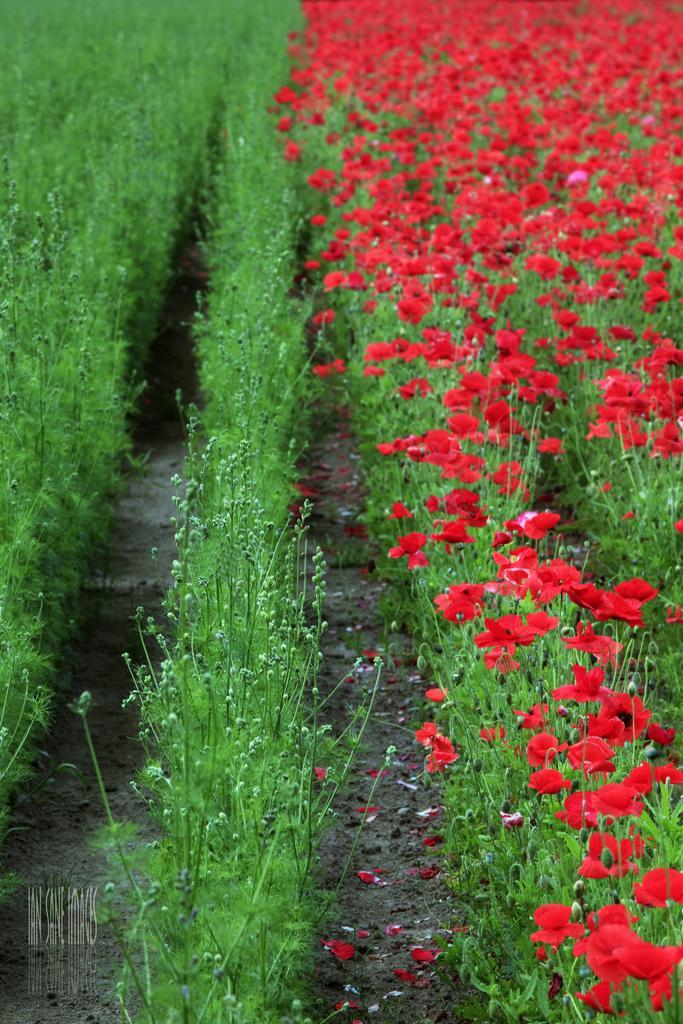Can you describe this image briefly? On the right side of the picture we can see red color flowers to the plants and on the left side of the picture we can see green color plants. Here we can see the watermark on the bottom left side of the image. 